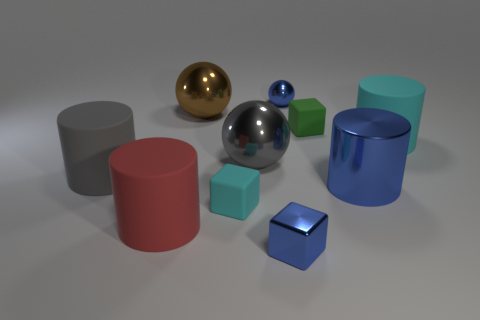There is a shiny cube; is it the same color as the tiny ball that is behind the big metal cylinder?
Offer a terse response. Yes. The shiny cylinder that is the same color as the tiny sphere is what size?
Provide a short and direct response. Large. Is there a large metallic cylinder that has the same color as the tiny metal ball?
Provide a succinct answer. Yes. There is a metallic cylinder that is the same size as the brown ball; what is its color?
Your answer should be compact. Blue. There is a metallic sphere that is behind the large brown shiny sphere; what number of large metallic things are on the right side of it?
Your answer should be very brief. 1. How many things are big cylinders to the left of the large cyan matte thing or gray matte cylinders?
Provide a short and direct response. 3. How many large gray objects have the same material as the brown thing?
Provide a short and direct response. 1. There is a large object that is the same color as the shiny block; what shape is it?
Provide a short and direct response. Cylinder. Is the number of shiny things to the right of the brown thing the same as the number of small blue cubes?
Give a very brief answer. No. How big is the matte cylinder on the right side of the tiny shiny cube?
Provide a succinct answer. Large. 